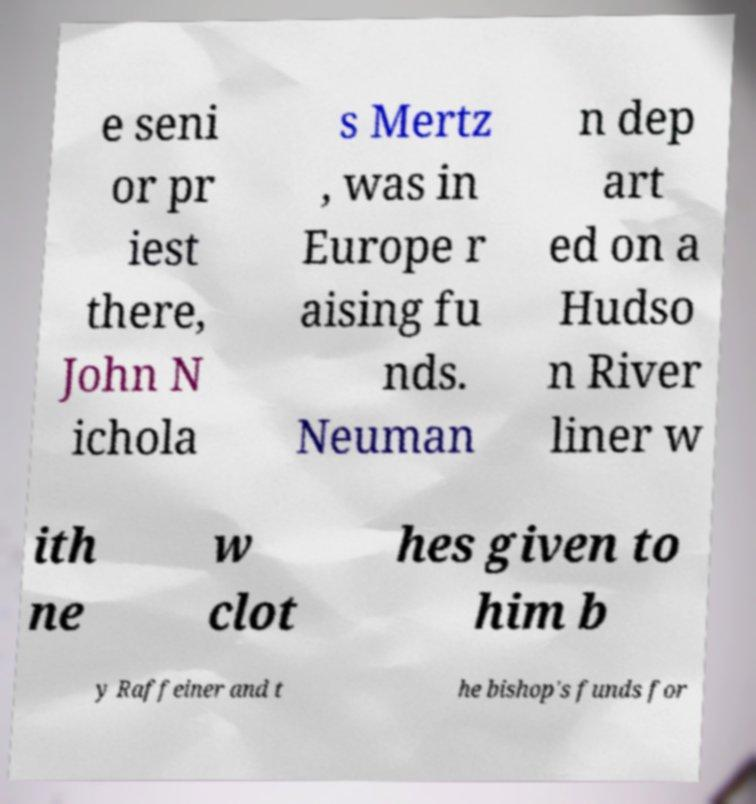Please identify and transcribe the text found in this image. e seni or pr iest there, John N ichola s Mertz , was in Europe r aising fu nds. Neuman n dep art ed on a Hudso n River liner w ith ne w clot hes given to him b y Raffeiner and t he bishop's funds for 